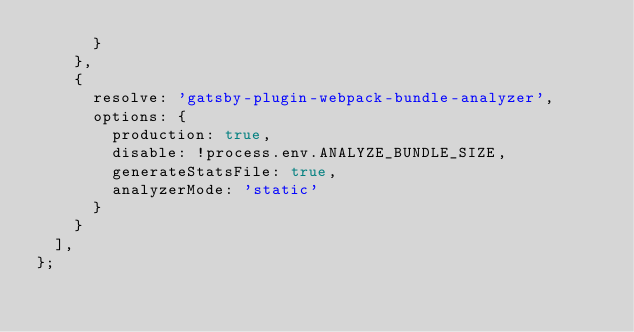<code> <loc_0><loc_0><loc_500><loc_500><_JavaScript_>      }
    },
    {
      resolve: 'gatsby-plugin-webpack-bundle-analyzer',
      options: {
        production: true,
        disable: !process.env.ANALYZE_BUNDLE_SIZE,
        generateStatsFile: true,
        analyzerMode: 'static'
      }
    }
  ],
};
</code> 